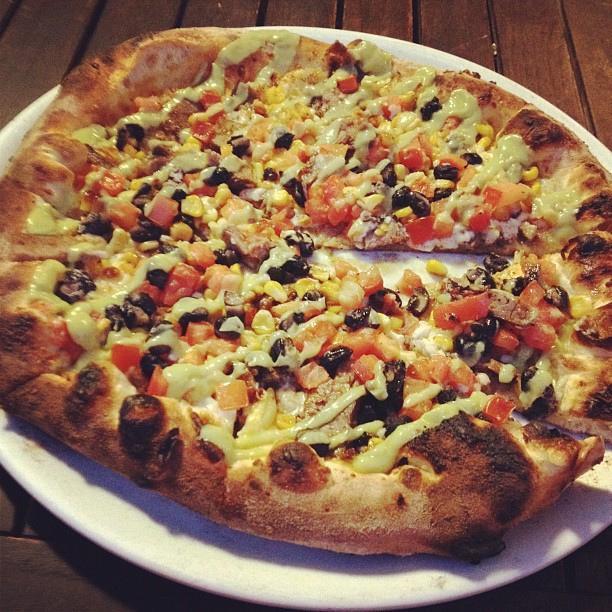How many pizzas on the table?
Give a very brief answer. 1. 